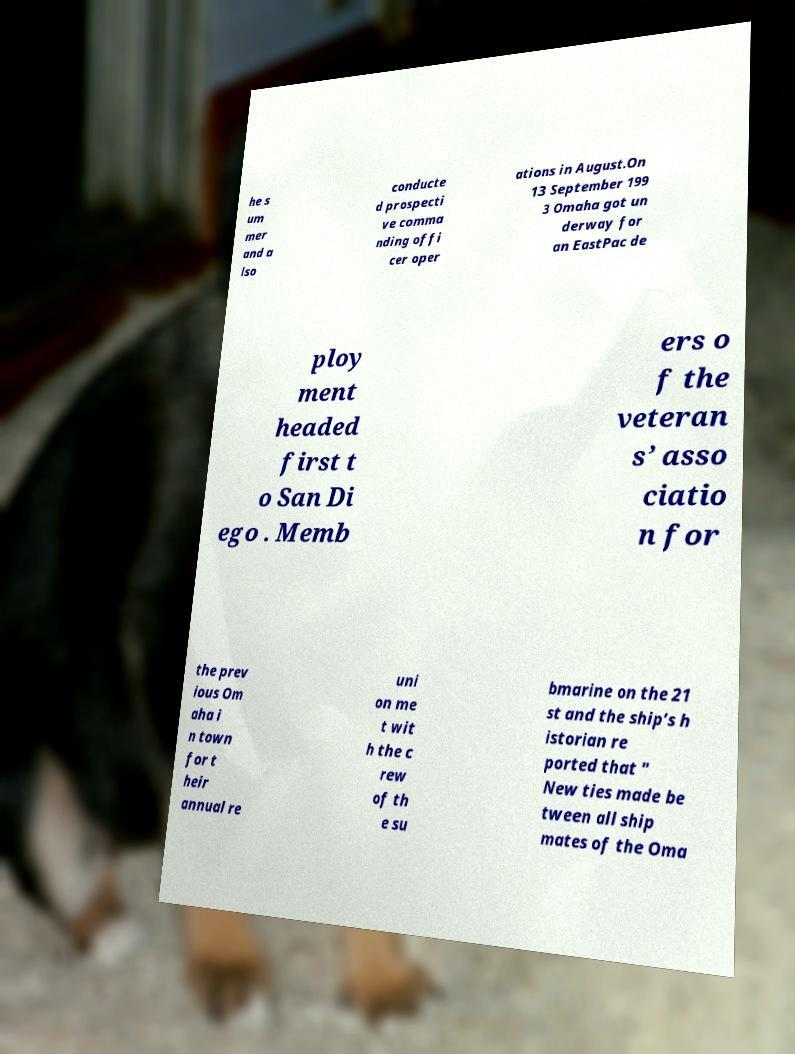Could you extract and type out the text from this image? he s um mer and a lso conducte d prospecti ve comma nding offi cer oper ations in August.On 13 September 199 3 Omaha got un derway for an EastPac de ploy ment headed first t o San Di ego . Memb ers o f the veteran s’ asso ciatio n for the prev ious Om aha i n town for t heir annual re uni on me t wit h the c rew of th e su bmarine on the 21 st and the ship’s h istorian re ported that " New ties made be tween all ship mates of the Oma 